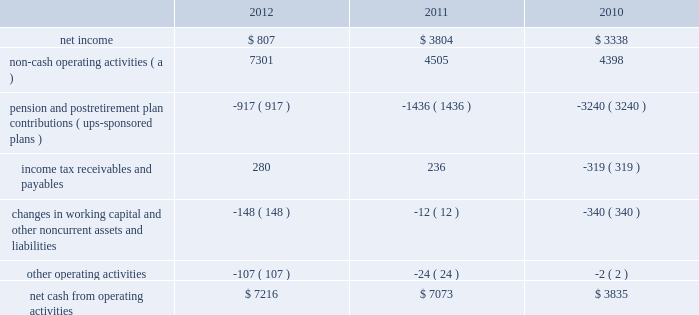United parcel service , inc .
And subsidiaries management's discussion and analysis of financial condition and results of operations liquidity and capital resources operating activities the following is a summary of the significant sources ( uses ) of cash from operating activities ( amounts in millions ) : .
( a ) represents depreciation and amortization , gains and losses on derivative and foreign exchange transactions , deferred income taxes , provisions for uncollectible accounts , pension and postretirement benefit expense , stock compensation expense , impairment charges and other non-cash items .
Cash from operating activities remained strong throughout the 2010 to 2012 time period .
Operating cash flow was favorably impacted in 2012 , compared with 2011 , by lower contributions into our defined benefit pension and postretirement benefit plans ; however , this was partially offset by changes in our working capital position , which was impacted by overall growth in the business .
The change in the cash flows for income tax receivables and payables in 2011 and 2010 was primarily related to the timing of discretionary pension contributions during 2010 , as discussed further in the following paragraph .
Except for discretionary or accelerated fundings of our plans , contributions to our company-sponsored pension plans have largely varied based on whether any minimum funding requirements are present for individual pension plans .
2022 in 2012 , we made a $ 355 million required contribution to the ups ibt pension plan .
2022 in 2011 , we made a $ 1.2 billion contribution to the ups ibt pension plan , which satisfied our 2011 contribution requirements and also approximately $ 440 million in contributions that would not have been required until after 2011 .
2022 in 2010 , we made $ 2.0 billion in discretionary contributions to our ups retirement and ups pension plans , and $ 980 million in required contributions to our ups ibt pension plan .
2022 the remaining contributions in the 2010 through 2012 period were largely due to contributions to our international pension plans and u.s .
Postretirement medical benefit plans .
As discussed further in the 201ccontractual commitments 201d section , we have minimum funding requirements in the next several years , primarily related to the ups ibt pension , ups retirement and ups pension plans .
As of december 31 , 2012 , the total of our worldwide holdings of cash and cash equivalents was $ 7.327 billion .
Approximately $ 4.211 billion of this amount was held in european subsidiaries with the intended purpose of completing the acquisition of tnt express n.v .
( see note 16 to the consolidated financial statements ) .
Excluding this portion of cash held outside the u.s .
For acquisition-related purposes , approximately 50%-60% ( 50%-60 % ) of the remaining cash and cash equivalents are held by foreign subsidiaries throughout the year .
The amount of cash held by our u.s .
And foreign subsidiaries fluctuates throughout the year due to a variety of factors , including the timing of cash receipts and disbursements in the normal course of business .
Cash provided by operating activities in the united states continues to be our primary source of funds to finance domestic operating needs , capital expenditures , share repurchases and dividend payments to shareowners .
To the extent that such amounts represent previously untaxed earnings , the cash held by foreign subsidiaries would be subject to tax if such amounts were repatriated in the form of dividends ; however , not all international cash balances would have to be repatriated in the form of a dividend if returned to the u.s .
When amounts earned by foreign subsidiaries are expected to be indefinitely reinvested , no accrual for taxes is provided. .
What was the percentage change in net cash from operating activities from 2011 to 2012? 
Computations: ((7216 - 7073) / 7073)
Answer: 0.02022. United parcel service , inc .
And subsidiaries management's discussion and analysis of financial condition and results of operations liquidity and capital resources operating activities the following is a summary of the significant sources ( uses ) of cash from operating activities ( amounts in millions ) : .
( a ) represents depreciation and amortization , gains and losses on derivative and foreign exchange transactions , deferred income taxes , provisions for uncollectible accounts , pension and postretirement benefit expense , stock compensation expense , impairment charges and other non-cash items .
Cash from operating activities remained strong throughout the 2010 to 2012 time period .
Operating cash flow was favorably impacted in 2012 , compared with 2011 , by lower contributions into our defined benefit pension and postretirement benefit plans ; however , this was partially offset by changes in our working capital position , which was impacted by overall growth in the business .
The change in the cash flows for income tax receivables and payables in 2011 and 2010 was primarily related to the timing of discretionary pension contributions during 2010 , as discussed further in the following paragraph .
Except for discretionary or accelerated fundings of our plans , contributions to our company-sponsored pension plans have largely varied based on whether any minimum funding requirements are present for individual pension plans .
2022 in 2012 , we made a $ 355 million required contribution to the ups ibt pension plan .
2022 in 2011 , we made a $ 1.2 billion contribution to the ups ibt pension plan , which satisfied our 2011 contribution requirements and also approximately $ 440 million in contributions that would not have been required until after 2011 .
2022 in 2010 , we made $ 2.0 billion in discretionary contributions to our ups retirement and ups pension plans , and $ 980 million in required contributions to our ups ibt pension plan .
2022 the remaining contributions in the 2010 through 2012 period were largely due to contributions to our international pension plans and u.s .
Postretirement medical benefit plans .
As discussed further in the 201ccontractual commitments 201d section , we have minimum funding requirements in the next several years , primarily related to the ups ibt pension , ups retirement and ups pension plans .
As of december 31 , 2012 , the total of our worldwide holdings of cash and cash equivalents was $ 7.327 billion .
Approximately $ 4.211 billion of this amount was held in european subsidiaries with the intended purpose of completing the acquisition of tnt express n.v .
( see note 16 to the consolidated financial statements ) .
Excluding this portion of cash held outside the u.s .
For acquisition-related purposes , approximately 50%-60% ( 50%-60 % ) of the remaining cash and cash equivalents are held by foreign subsidiaries throughout the year .
The amount of cash held by our u.s .
And foreign subsidiaries fluctuates throughout the year due to a variety of factors , including the timing of cash receipts and disbursements in the normal course of business .
Cash provided by operating activities in the united states continues to be our primary source of funds to finance domestic operating needs , capital expenditures , share repurchases and dividend payments to shareowners .
To the extent that such amounts represent previously untaxed earnings , the cash held by foreign subsidiaries would be subject to tax if such amounts were repatriated in the form of dividends ; however , not all international cash balances would have to be repatriated in the form of a dividend if returned to the u.s .
When amounts earned by foreign subsidiaries are expected to be indefinitely reinvested , no accrual for taxes is provided. .
What is the growth rate in the net income from 2011 to 2012? 
Computations: ((807 - 3804) / 3804)
Answer: -0.78785. 